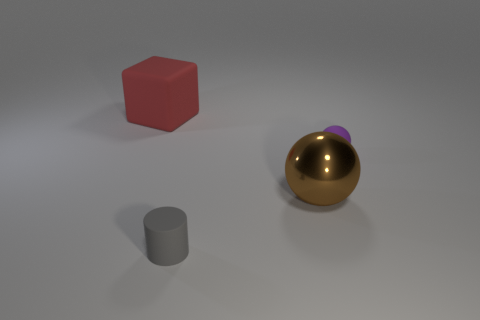There is a rubber object in front of the object that is on the right side of the big brown shiny sphere; what is its shape?
Offer a very short reply. Cylinder. Are there fewer tiny purple objects that are right of the rubber sphere than purple matte spheres?
Your answer should be very brief. Yes. What number of purple rubber objects have the same size as the shiny sphere?
Your response must be concise. 0. There is a large thing that is in front of the tiny purple ball; what shape is it?
Give a very brief answer. Sphere. Is the number of brown shiny balls less than the number of things?
Keep it short and to the point. Yes. Are there any other things that have the same color as the big ball?
Ensure brevity in your answer.  No. There is a rubber object to the right of the matte cylinder; what is its size?
Provide a short and direct response. Small. Is the number of small gray matte things greater than the number of tiny cyan metallic blocks?
Offer a very short reply. Yes. What is the large block made of?
Provide a succinct answer. Rubber. What number of other things are there of the same material as the gray cylinder
Give a very brief answer. 2. 